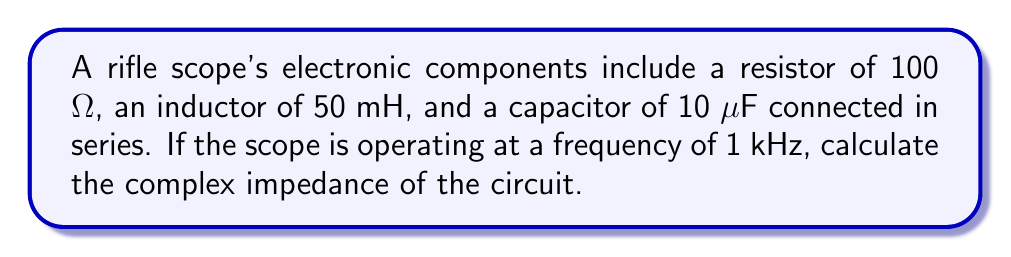Can you answer this question? To calculate the complex impedance, we need to follow these steps:

1. Calculate the inductive reactance:
   $X_L = 2\pi fL$
   $X_L = 2\pi \cdot 1000 \cdot 0.050 = 314.16$ Ω

2. Calculate the capacitive reactance:
   $X_C = \frac{1}{2\pi fC}$
   $X_C = \frac{1}{2\pi \cdot 1000 \cdot 10 \cdot 10^{-6}} = 15915.49$ Ω

3. The complex impedance is given by:
   $Z = R + j(X_L - X_C)$

   Where:
   $R = 100$ Ω (resistance)
   $j(X_L - X_C) = j(314.16 - 15915.49) = -j15601.33$ Ω

4. Combining the real and imaginary parts:
   $Z = 100 - j15601.33$ Ω

This can be written in polar form as:
$Z = \sqrt{100^2 + 15601.33^2} \angle \tan^{-1}(\frac{-15601.33}{100})$
$Z \approx 15601.37 \angle -89.63°$ Ω
Answer: $Z = 100 - j15601.33$ Ω 